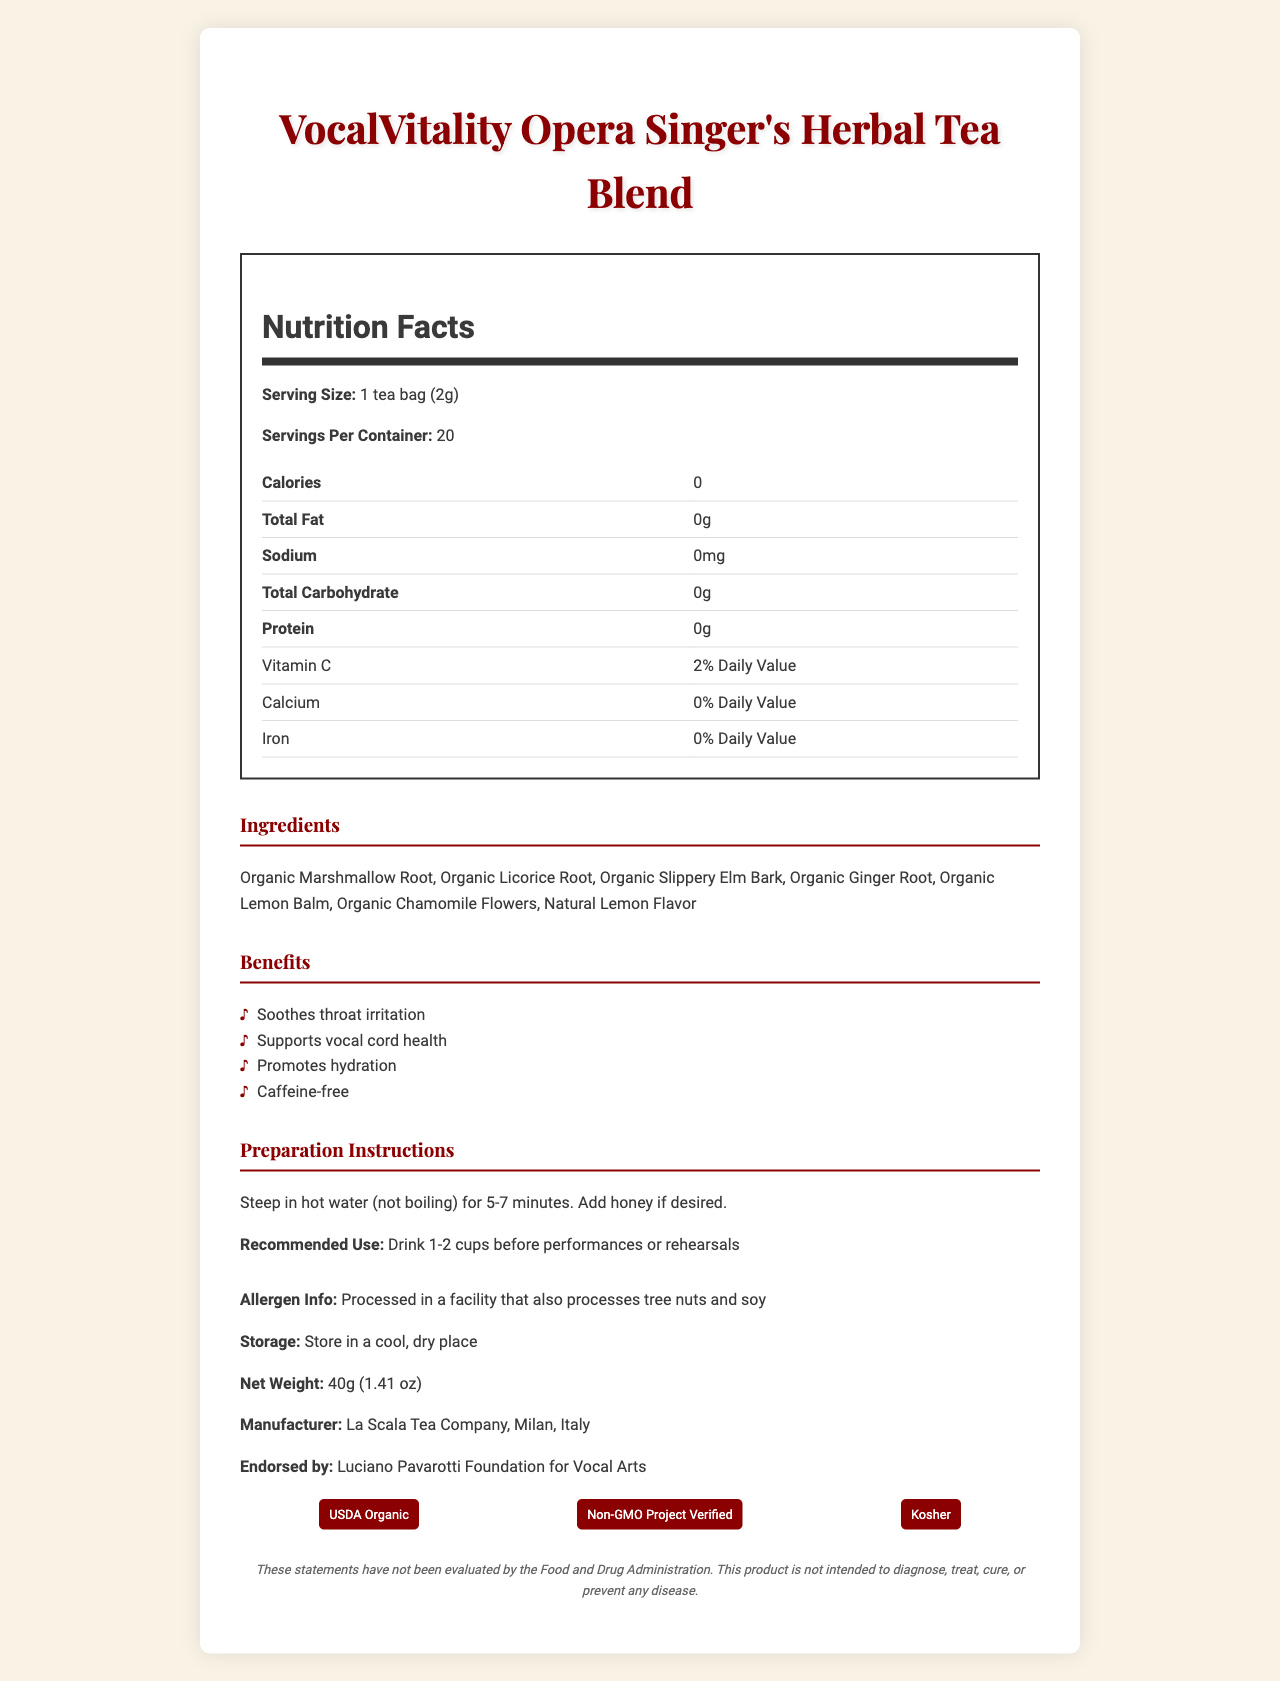How many servings are there per container? The document states that there are 20 servings per container.
Answer: 20 What is the serving size of the VocalVitality Herbal Tea Blend? The serving size is clearly indicated as 1 tea bag (2g).
Answer: 1 tea bag (2g) What is the calorie count per serving? According to the nutrition facts, there are 0 calories per serving.
Answer: 0 Which vitamin is present in this tea and what is its daily value percentage? The nutrition facts list Vitamin C with a 2% Daily Value percentage.
Answer: Vitamin C, 2% What is the main benefit of this tea for opera singers? One of the main benefits listed is that it soothes throat irritation.
Answer: Soothes throat irritation What endorsement does this tea blend have? The tea is endorsed by the Luciano Pavarotti Foundation for Vocal Arts, as mentioned in the document.
Answer: Luciano Pavarotti Foundation for Vocal Arts Is the product caffeine-free? The benefits section explicitly states that the tea is caffeine-free.
Answer: Yes What are the recommended preparation instructions for this tea? The preparation instructions are to steep the tea in hot water (not boiling) for 5-7 minutes and to add honey if desired.
Answer: Steep in hot water (not boiling) for 5-7 minutes. Add honey if desired. Where is this product manufactured? The document states that the product is manufactured by La Scala Tea Company in Milan, Italy.
Answer: La Scala Tea Company, Milan, Italy What certifications does this product hold? (Choose all that apply) A. USDA Organic B. Gluten-Free C. Non-GMO Project Verified D. Kosher The product holds certifications for USDA Organic, Non-GMO Project Verified, and Kosher.
Answer: A, C, D What allergens are mentioned in the document? A. Dairy B. Tree nuts C. Soy D. Shellfish The allergen information indicates that the product is processed in a facility that also processes tree nuts and soy.
Answer: B, C Does the tea contain protein? The nutrition facts specify that the tea contains 0g of protein.
Answer: No What is the overall purpose of this document? The document is a comprehensive presentation of the product, aiming to inform consumers about its various aspects such as nutrition facts, ingredients, health benefits, preparation, and certifications.
Answer: To provide detailed information about the VocalVitality Opera Singer's Herbal Tea Blend, including its nutritional content, benefits, ingredients, preparation instructions, and certifications. What is the net weight of the product? The document states that the net weight of the product is 40g (1.41 oz).
Answer: 40g (1.41 oz) Can the exact percentage of Calcium be identified from the document? The nutrition facts state that the product contains 0% Daily Value of Calcium.
Answer: 0% Daily Value What kind of flowers are included in the ingredient list? The ingredient list mentions Organic Chamomile Flowers.
Answer: Organic Chamomile Flowers Which benefit is NOT listed for the VocalVitality Opera Singer's Herbal Tea Blend? A. Soothes throat B. Supports heart health C. Promotes hydration D. Supports vocal cord health Supports heart health is not listed as one of the benefits of the tea.
Answer: B Can the specific origin of the ingredients be determined from the document? The document lists the ingredients but does not specify their origins.
Answer: Not enough information 